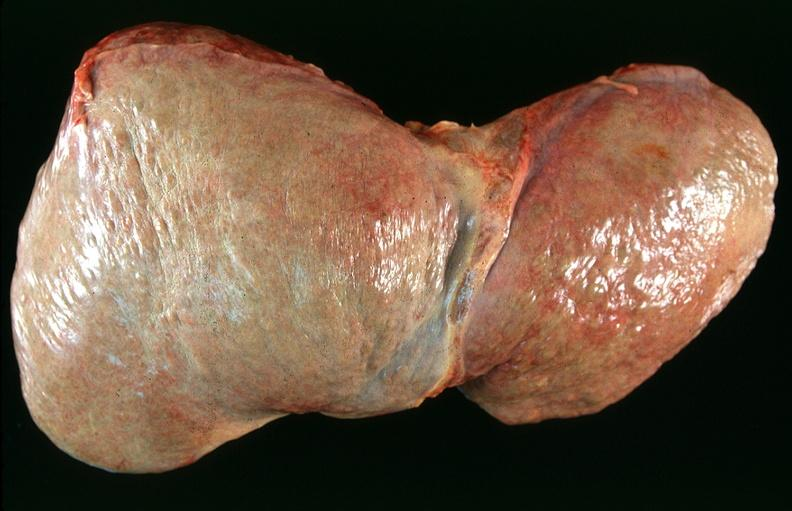does this image show liver, cirrhosis alpha-1 antitrypsin deficiency?
Answer the question using a single word or phrase. Yes 